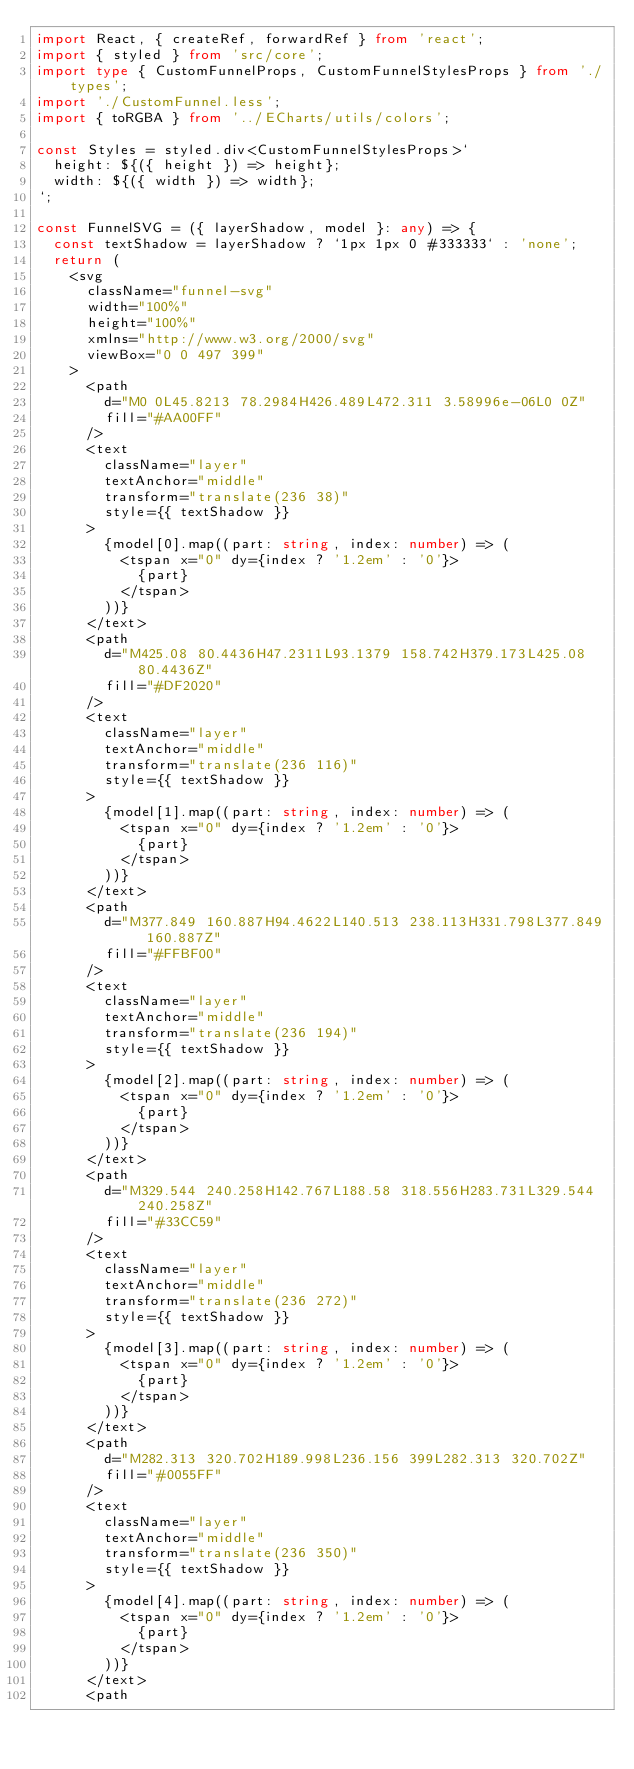<code> <loc_0><loc_0><loc_500><loc_500><_TypeScript_>import React, { createRef, forwardRef } from 'react';
import { styled } from 'src/core';
import type { CustomFunnelProps, CustomFunnelStylesProps } from './types';
import './CustomFunnel.less';
import { toRGBA } from '../ECharts/utils/colors';

const Styles = styled.div<CustomFunnelStylesProps>`
  height: ${({ height }) => height};
  width: ${({ width }) => width};
`;

const FunnelSVG = ({ layerShadow, model }: any) => {
  const textShadow = layerShadow ? `1px 1px 0 #333333` : 'none';
  return (
    <svg
      className="funnel-svg"
      width="100%"
      height="100%"
      xmlns="http://www.w3.org/2000/svg"
      viewBox="0 0 497 399"
    >
      <path
        d="M0 0L45.8213 78.2984H426.489L472.311 3.58996e-06L0 0Z"
        fill="#AA00FF"
      />
      <text
        className="layer"
        textAnchor="middle"
        transform="translate(236 38)"
        style={{ textShadow }}
      >
        {model[0].map((part: string, index: number) => (
          <tspan x="0" dy={index ? '1.2em' : '0'}>
            {part}
          </tspan>
        ))}
      </text>
      <path
        d="M425.08 80.4436H47.2311L93.1379 158.742H379.173L425.08 80.4436Z"
        fill="#DF2020"
      />
      <text
        className="layer"
        textAnchor="middle"
        transform="translate(236 116)"
        style={{ textShadow }}
      >
        {model[1].map((part: string, index: number) => (
          <tspan x="0" dy={index ? '1.2em' : '0'}>
            {part}
          </tspan>
        ))}
      </text>
      <path
        d="M377.849 160.887H94.4622L140.513 238.113H331.798L377.849 160.887Z"
        fill="#FFBF00"
      />
      <text
        className="layer"
        textAnchor="middle"
        transform="translate(236 194)"
        style={{ textShadow }}
      >
        {model[2].map((part: string, index: number) => (
          <tspan x="0" dy={index ? '1.2em' : '0'}>
            {part}
          </tspan>
        ))}
      </text>
      <path
        d="M329.544 240.258H142.767L188.58 318.556H283.731L329.544 240.258Z"
        fill="#33CC59"
      />
      <text
        className="layer"
        textAnchor="middle"
        transform="translate(236 272)"
        style={{ textShadow }}
      >
        {model[3].map((part: string, index: number) => (
          <tspan x="0" dy={index ? '1.2em' : '0'}>
            {part}
          </tspan>
        ))}
      </text>
      <path
        d="M282.313 320.702H189.998L236.156 399L282.313 320.702Z"
        fill="#0055FF"
      />
      <text
        className="layer"
        textAnchor="middle"
        transform="translate(236 350)"
        style={{ textShadow }}
      >
        {model[4].map((part: string, index: number) => (
          <tspan x="0" dy={index ? '1.2em' : '0'}>
            {part}
          </tspan>
        ))}
      </text>
      <path</code> 